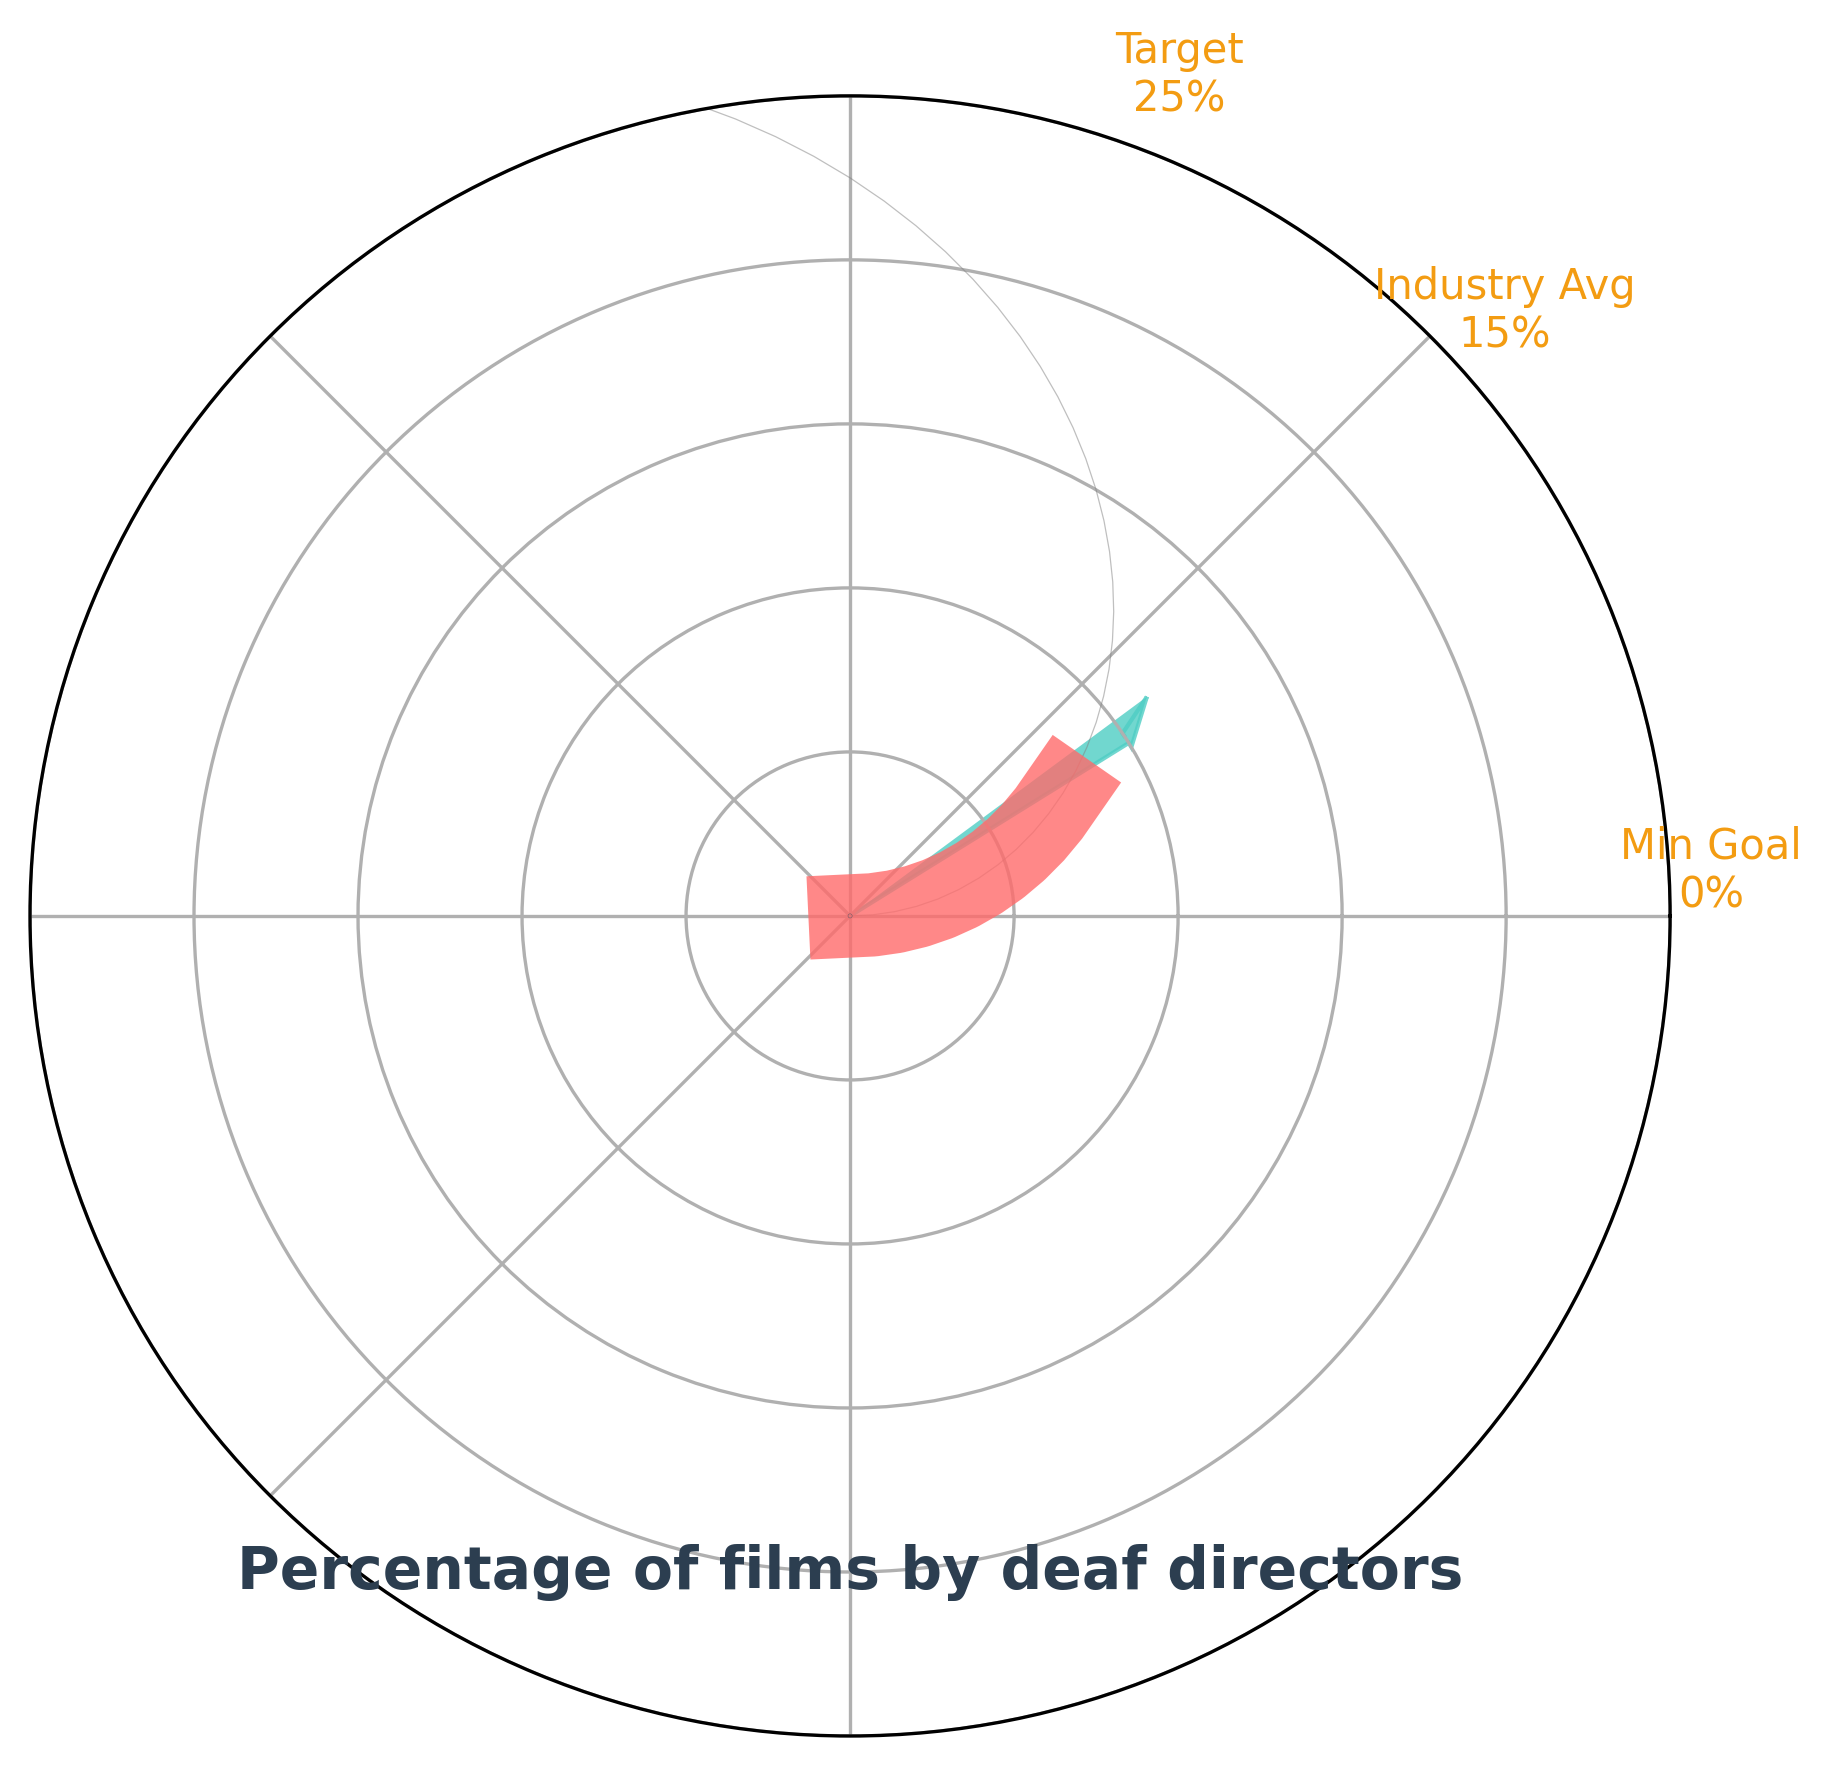How many additional data points are shown besides the main percentage value? The plot shows additional data points labeled as "Min Goal," "Industry Avg," and "Target," so there are three additional data points.
Answer: 3 What is the current percentage of films by deaf directors in the festival lineup? The main percentage value displayed in the gauge chart indicates the current representation of deaf directors, which is 12%.
Answer: 12% How does the current percentage of films by deaf directors compare to the minimum representation goal? The minimum representation goal is shown at 0%, while the current percentage is 12%. Therefore, the current percentage is 12% higher than the minimum goal.
Answer: 12% higher Is the current representation of films by deaf directors above the industry average? The industry average is marked at 15%. Since the current percentage is 12%, it is below the industry average.
Answer: Below What is the difference between the festival target and the industry average for the percentage of films by deaf directors? The festival target is 25%, and the industry average is 15%. The difference between these two values is 25% - 15% = 10%.
Answer: 10% What color is used to represent the main percentage value in the gauge chart? The part of the gauge chart representing the main percentage value (12%) is colored in a shade of red.
Answer: Red What is the value at which the needle is pointing on the gauge chart? The needle on the gauge chart is pointing at 12%, indicating the current percentage of films by deaf directors.
Answer: 12% Which labeled data point is the highest on the gauge chart? The highest labeled data point is the "Maximum possible percentage," set at 100%.
Answer: Maximum possible percentage What does the percentage at which the needle is pointing represent? The percentage at which the needle is pointing represents the current percentage of films by deaf directors in the festival lineup.
Answer: Current percentage By how much does the current percentage of films by deaf directors fall short of the festival target? The festival target is 25%, and the current percentage is 12%. The shortfall is 25% - 12% = 13%.
Answer: 13% short 